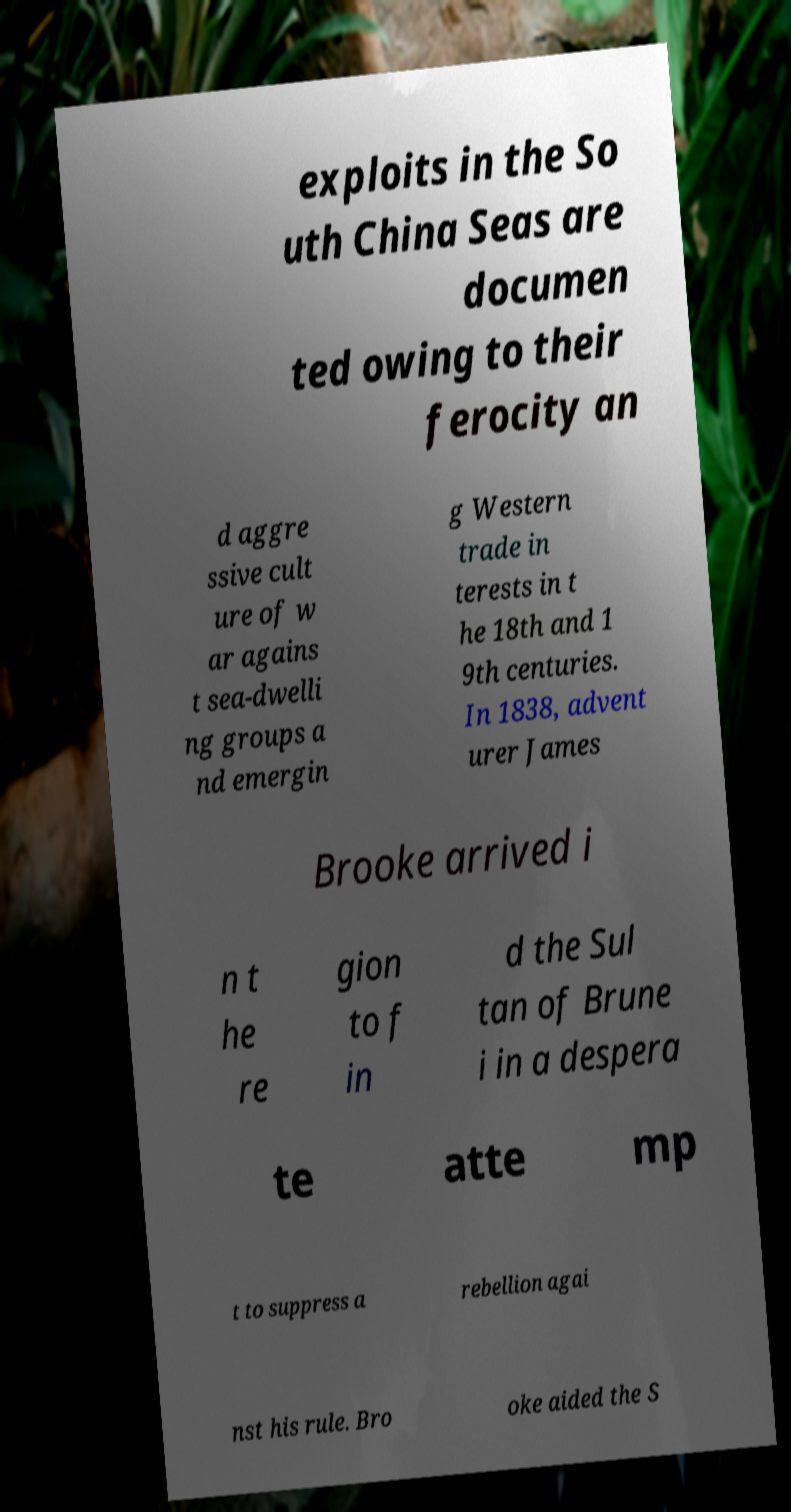Could you extract and type out the text from this image? exploits in the So uth China Seas are documen ted owing to their ferocity an d aggre ssive cult ure of w ar agains t sea-dwelli ng groups a nd emergin g Western trade in terests in t he 18th and 1 9th centuries. In 1838, advent urer James Brooke arrived i n t he re gion to f in d the Sul tan of Brune i in a despera te atte mp t to suppress a rebellion agai nst his rule. Bro oke aided the S 